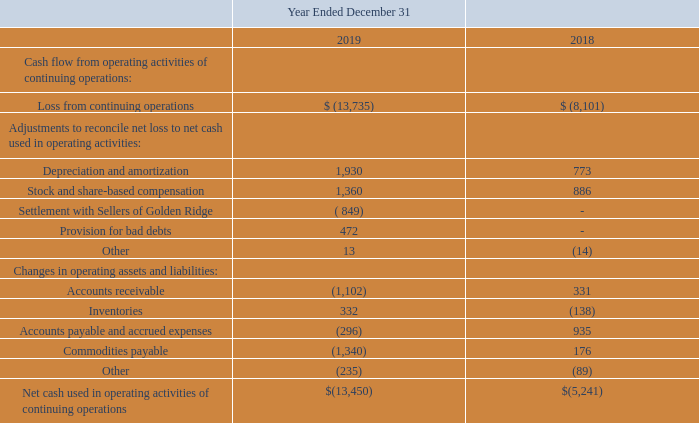Liquidity, Going Concern and Capital Resources
See Note 1 of our Notes to Consolidated Financial Statements for a discussion of liquidity.
Cash used in operating activities of continuing operations is presented below (in thousands).
We used $13.5 million in operating cash during 2019, compared to $5.2 million of operating cash in 2018. We also funded $4.4 million of capital expenditures in 2019, compared to $3.3 million in the prior year. These capital expenditures relate primarily to our capacity expansion and debottlenecking at Golden Ridge, leasehold improvements at our Riverside facility, and our specialty ingredients’ equipment in our Dillon plant. Offsetting these uses of cash was $19.4 million of proceeds from issuances of common stock and a prefunded warrant, as well as $2.2 million of proceeds from option and warrant exercises.
As of December 31, 2019, our cash and cash equivalents balance was $8.4 million (see Note 1), compared to $7.0 million and $0.2 million of restricted cash as of December 31, 2018. As of December 31, 2019, management believes the Company has sufficient capital reserves and borrowing capacity to fund the operations of the business; however, we may seek external sources of funding for investment initiatives and/or general operations if we determine that is the best course of action.
What are the respective loss from continuing operations in 2018 and 2019?
Answer scale should be: thousand. 8,101, 13,735. What are the respective adjustments to depreciation and amortization in 2018 and 2019?
Answer scale should be: thousand. 773, 1,930. What are the respective adjustments to stock and share-based compensation in 2018 and 2019?
Answer scale should be: thousand. 886, 1,360. What is the average loss from continuing operations in 2018 and 2019?
Answer scale should be: thousand. (8,101 + 13,735)/2 
Answer: 10918. What is the percentage change in adjustment in depreciation and amortization in 2018 and 2019?
Answer scale should be: percent. (1,930 - 773)/773 
Answer: 149.68. What is the percentage change in adjustments to stock and share-based compensation in 2018 and 2019?
Answer scale should be: percent. (1,360 - 886)/886 
Answer: 53.5. 